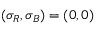<formula> <loc_0><loc_0><loc_500><loc_500>( \sigma _ { R } , \sigma _ { B } ) = ( 0 , 0 )</formula> 